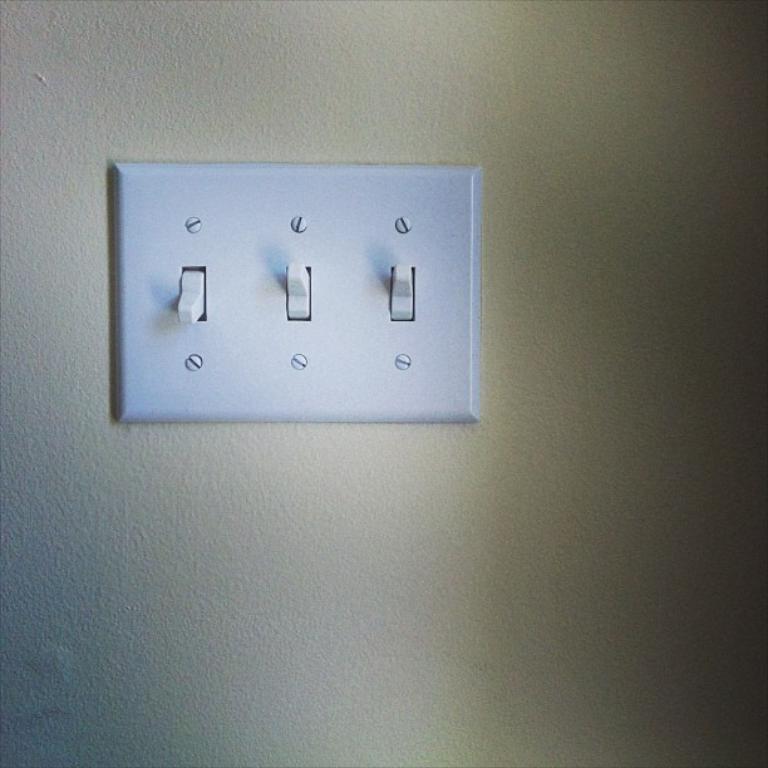Describe this image in one or two sentences. In the middle of the image there is a switchboard on the wall. The switchboard is white in color and there are a few switches and screws. 